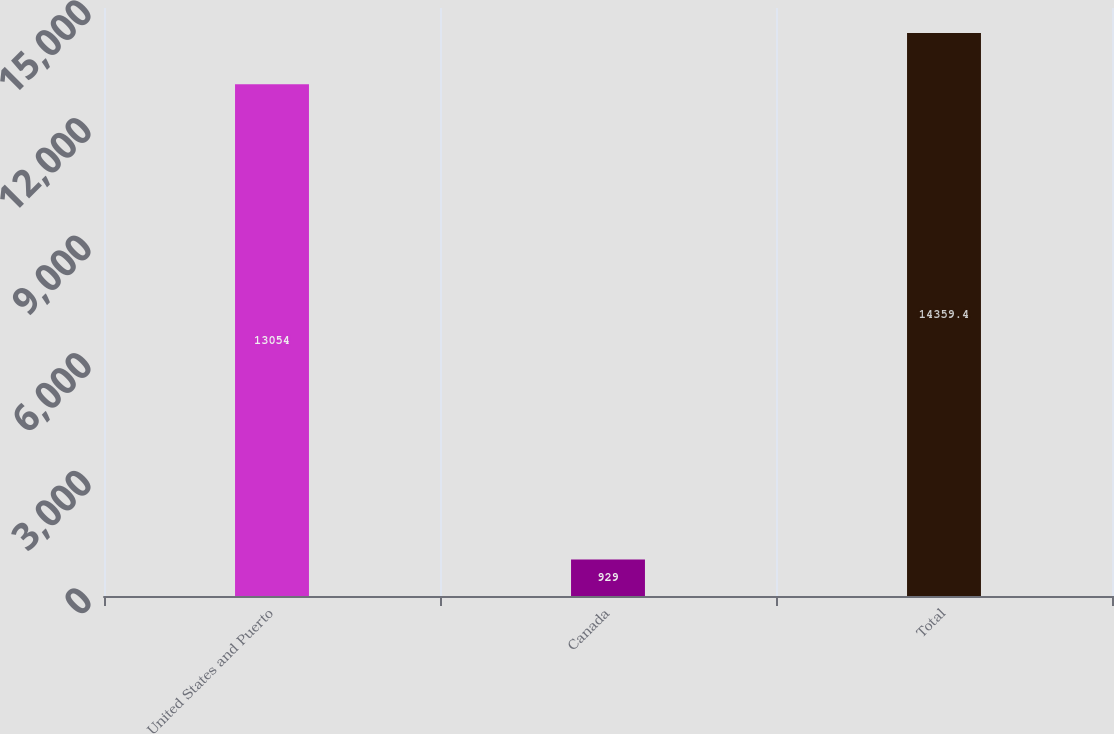<chart> <loc_0><loc_0><loc_500><loc_500><bar_chart><fcel>United States and Puerto<fcel>Canada<fcel>Total<nl><fcel>13054<fcel>929<fcel>14359.4<nl></chart> 